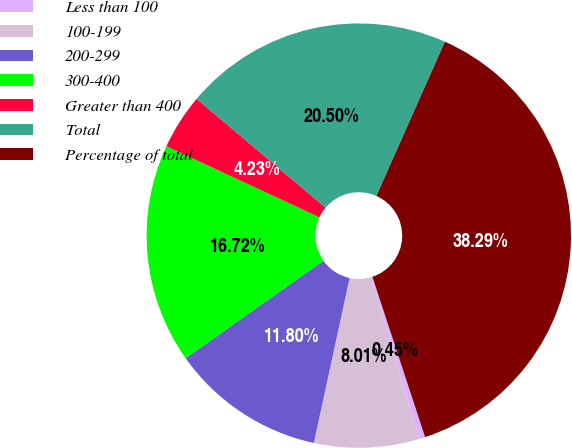Convert chart. <chart><loc_0><loc_0><loc_500><loc_500><pie_chart><fcel>Less than 100<fcel>100-199<fcel>200-299<fcel>300-400<fcel>Greater than 400<fcel>Total<fcel>Percentage of total<nl><fcel>0.45%<fcel>8.01%<fcel>11.8%<fcel>16.72%<fcel>4.23%<fcel>20.5%<fcel>38.29%<nl></chart> 